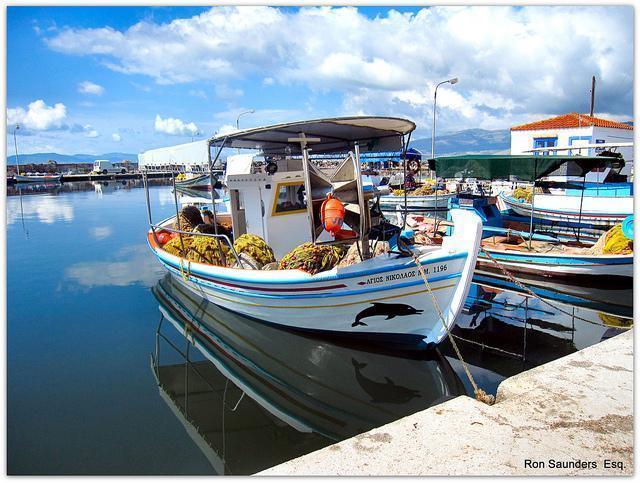What yellow items sits on the boat?
From the following four choices, select the correct answer to address the question.
Options: Stockings, bananas, net, mustard. Net. 